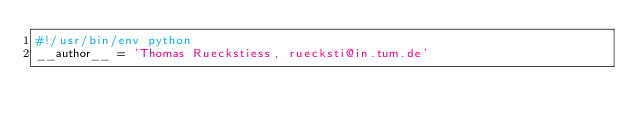<code> <loc_0><loc_0><loc_500><loc_500><_Python_>#!/usr/bin/env python
__author__ = 'Thomas Rueckstiess, ruecksti@in.tum.de'
</code> 